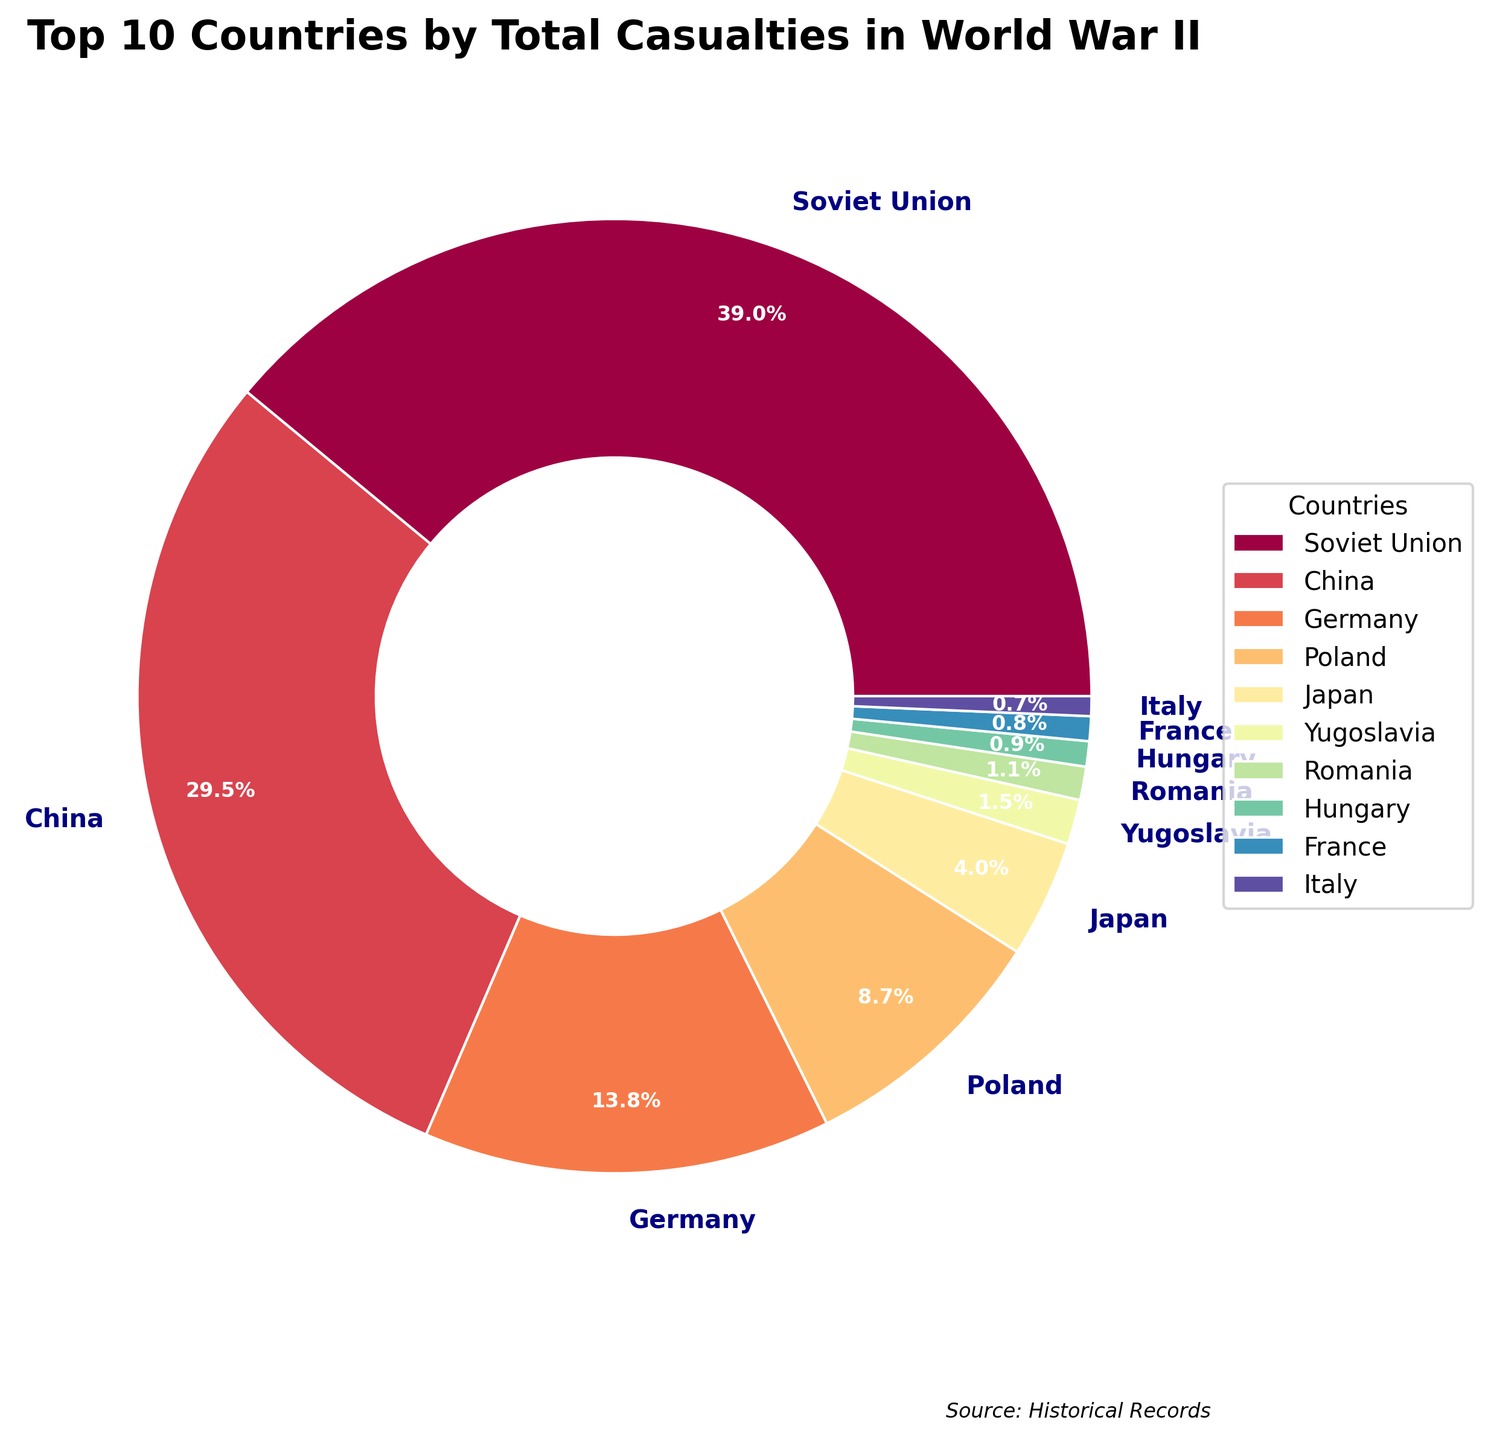Which country has the highest number of total casualties? According to the pie chart, the Soviet Union has the largest segment, indicating it has the highest total casualties.
Answer: Soviet Union How many total casualties did the United States have? The United States' segment is smaller, showing 528,100 total casualties (407,000 Military Deaths + 121,100 Civilian Deaths).
Answer: 528,100 Which country had more civilian deaths, China or Germany? From the pie chart, the segment for China is larger than Germany for civilian deaths.
Answer: China What is the combined total number of casualties for the United Kingdom and France? The UK's total casualties are 450,100 (383,000 Military Deaths + 67,100 Civilian Deaths) and France's are 567,000 (217,000 Military Deaths + 350,000 Civilian Deaths). Combined, they total 1,017,100.
Answer: 1,017,100 What is the approximate percentage of total casualties suffered by Poland? The pie chart shows proportions. Poland's segment roughly represents around 11.3% of the total casualties.
Answer: Approximately 11.3% Which country has the smallest number of casualties among the top 10 listed? The pie chart indicates that Czechoslovakia's share is the smallest among the top 10.
Answer: Czechoslovakia Compare the percentage of total casualties between Japan and Italy. Which one is higher? The pie chart shows Japan's segment is slightly larger than Italy's, meaning Japan has a higher percentage of total casualties.
Answer: Japan Which country among the top 10 has the least amount of civilian deaths? Reviewing the pie chart, Finland's segment for civilian deaths is the smallest among the top 10.
Answer: Finland How many more total casualties does the Soviet Union have compared to Germany? The Soviet Union has 26,533,000 total casualties (8,700,000 Military + 17,700,000 Civilian) compared to Germany's total of 9,313,000. The difference is 26,533,000 - 9,313,000 = 17,220,000.
Answer: 17,220,000 What is the combined percentage of total casualties for the Soviet Union and China? The pie chart suggests the Soviet Union has about 42.2% and China has about 23.3%. Combined, this is 42.2% + 23.3% = 65.5%.
Answer: 65.5% 